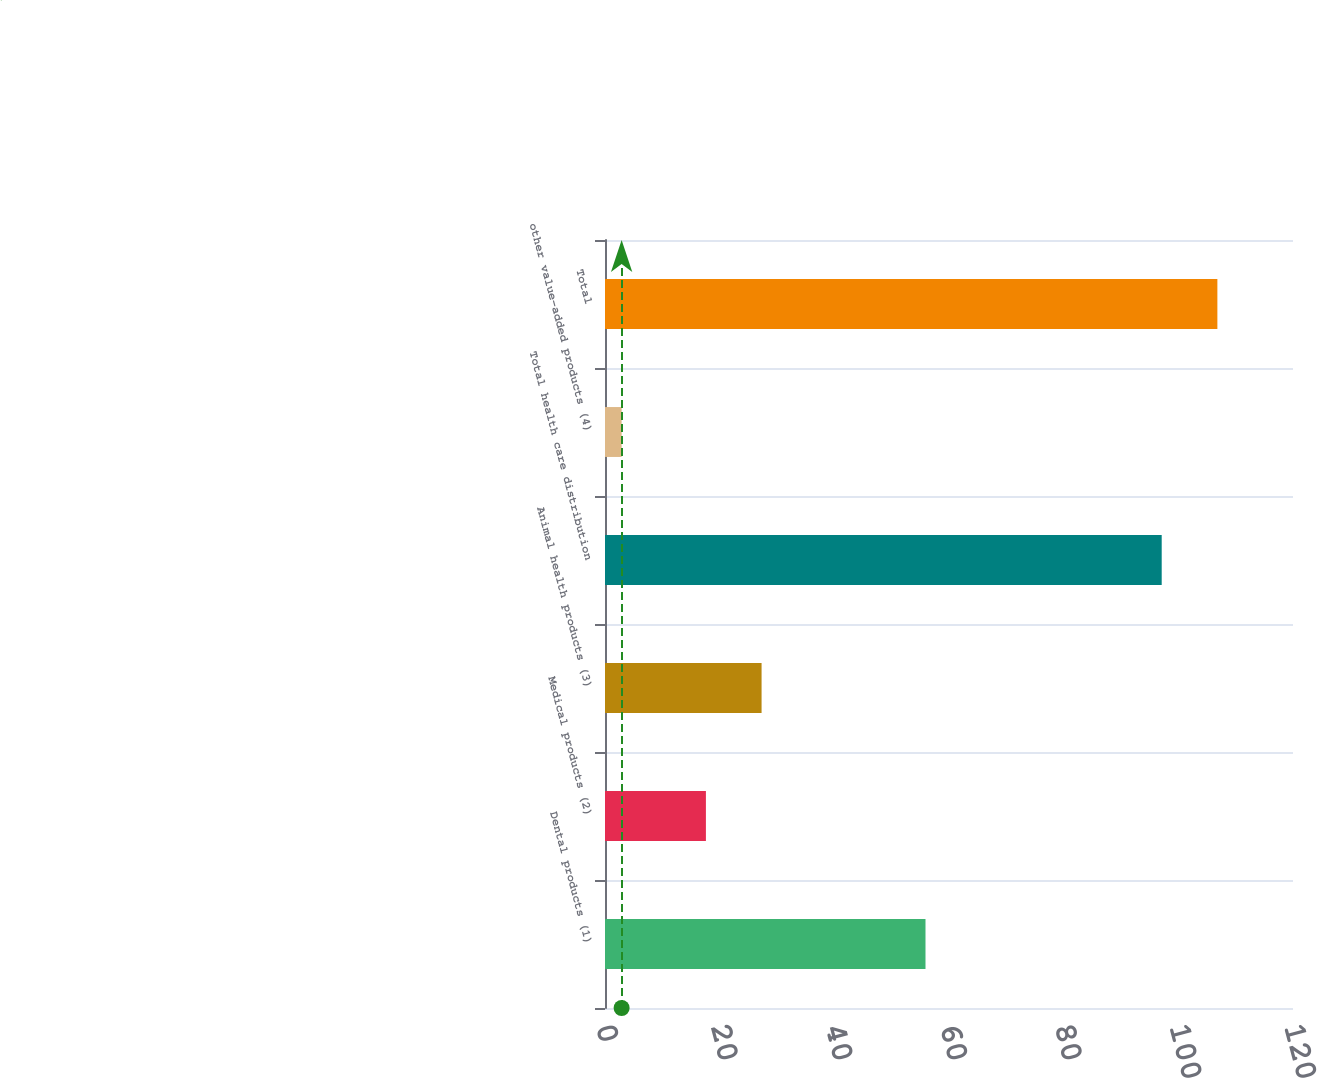<chart> <loc_0><loc_0><loc_500><loc_500><bar_chart><fcel>Dental products (1)<fcel>Medical products (2)<fcel>Animal health products (3)<fcel>Total health care distribution<fcel>other value-added products (4)<fcel>Total<nl><fcel>55.9<fcel>17.6<fcel>27.31<fcel>97.1<fcel>2.9<fcel>106.81<nl></chart> 